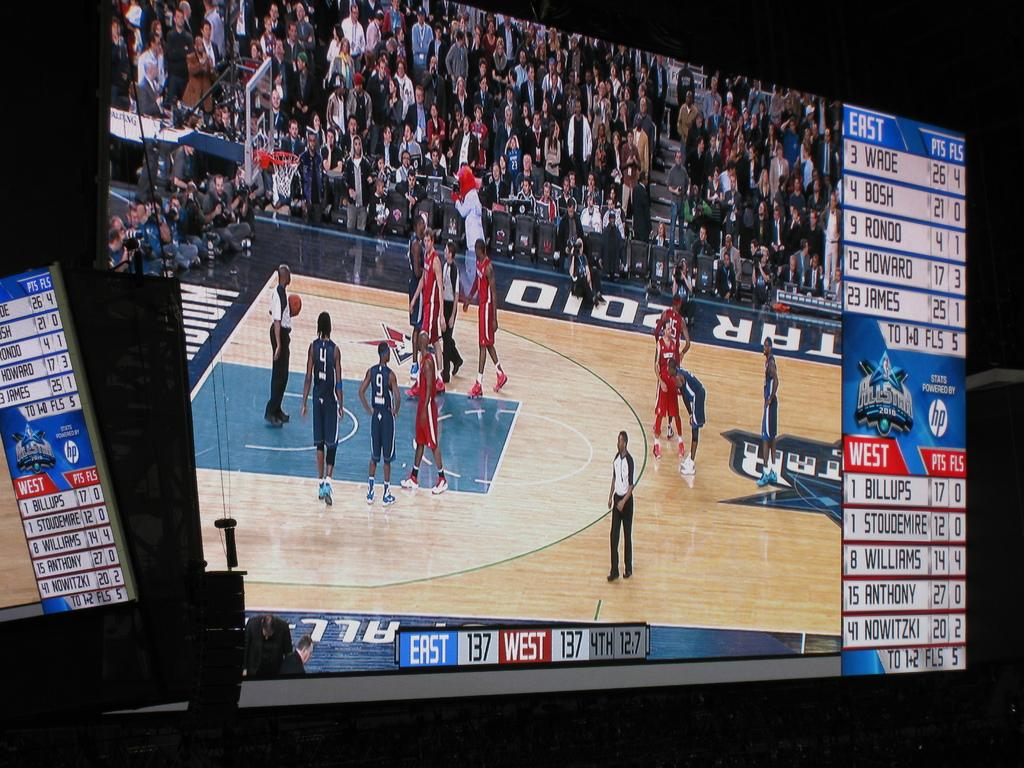<image>
Write a terse but informative summary of the picture. A basketball game is being shown on a tv screen with East 137 and West 137. 